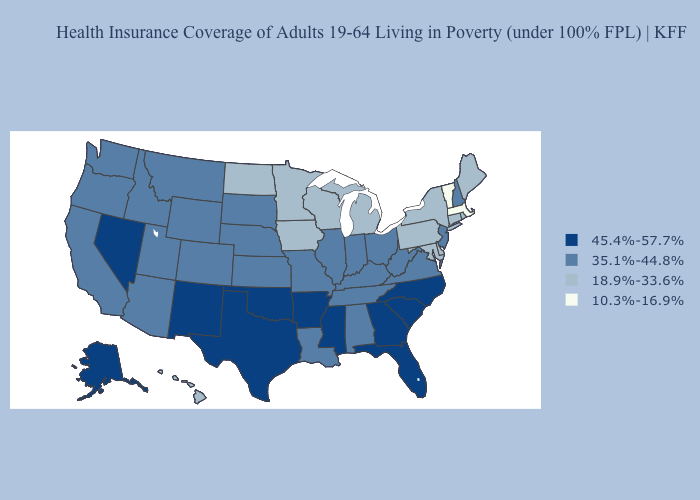Which states have the lowest value in the Northeast?
Give a very brief answer. Massachusetts, Vermont. What is the highest value in the USA?
Keep it brief. 45.4%-57.7%. Among the states that border Colorado , does Oklahoma have the highest value?
Be succinct. Yes. Does New Hampshire have the highest value in the Northeast?
Answer briefly. Yes. Name the states that have a value in the range 35.1%-44.8%?
Write a very short answer. Alabama, Arizona, California, Colorado, Idaho, Illinois, Indiana, Kansas, Kentucky, Louisiana, Missouri, Montana, Nebraska, New Hampshire, New Jersey, Ohio, Oregon, South Dakota, Tennessee, Utah, Virginia, Washington, West Virginia, Wyoming. What is the value of Idaho?
Be succinct. 35.1%-44.8%. Which states have the lowest value in the USA?
Be succinct. Massachusetts, Vermont. What is the lowest value in the USA?
Answer briefly. 10.3%-16.9%. Does Maine have a higher value than Massachusetts?
Answer briefly. Yes. What is the value of Louisiana?
Quick response, please. 35.1%-44.8%. Among the states that border Oregon , does Nevada have the highest value?
Keep it brief. Yes. Does Kansas have the highest value in the MidWest?
Concise answer only. Yes. Does Nevada have a higher value than Iowa?
Write a very short answer. Yes. What is the highest value in states that border Washington?
Quick response, please. 35.1%-44.8%. Name the states that have a value in the range 18.9%-33.6%?
Be succinct. Connecticut, Delaware, Hawaii, Iowa, Maine, Maryland, Michigan, Minnesota, New York, North Dakota, Pennsylvania, Rhode Island, Wisconsin. 